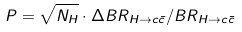<formula> <loc_0><loc_0><loc_500><loc_500>P = \sqrt { N _ { H } } \cdot \Delta B R _ { H \rightarrow c \bar { c } } / B R _ { H \rightarrow c \bar { c } }</formula> 